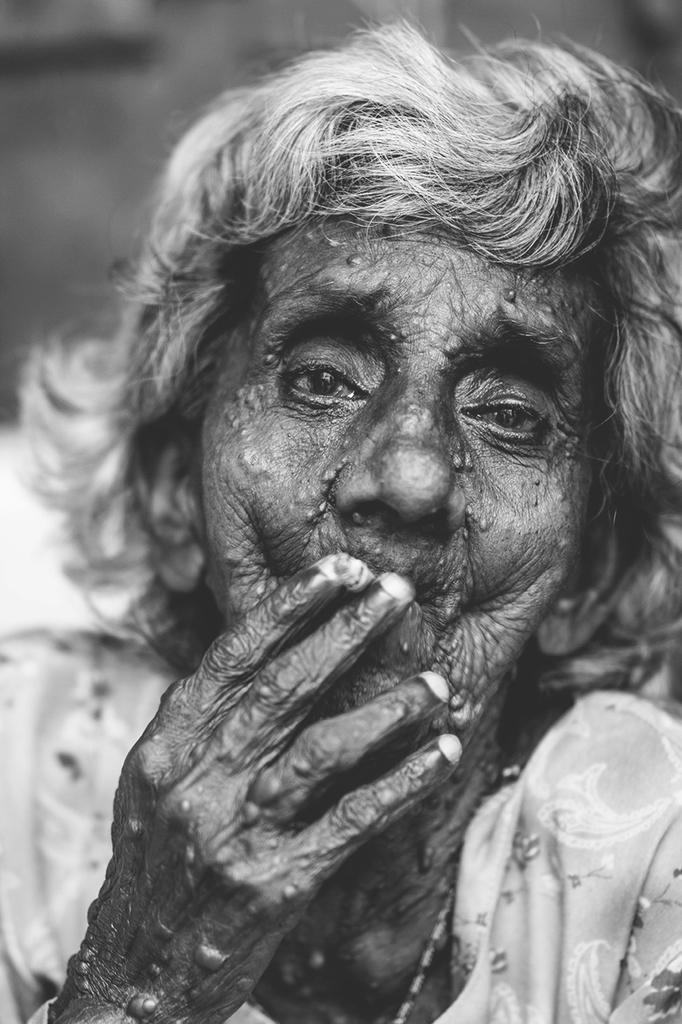What is the color scheme of the image? The image is black and white. Can you describe the main subject in the image? There is a woman in the image. What can be observed about the background of the image? The background of the image is blurred. How many rabbits are visible in the image? There are no rabbits present in the image. What type of pencil is the woman holding in the image? There is no pencil visible in the image, and the woman is not holding anything. 